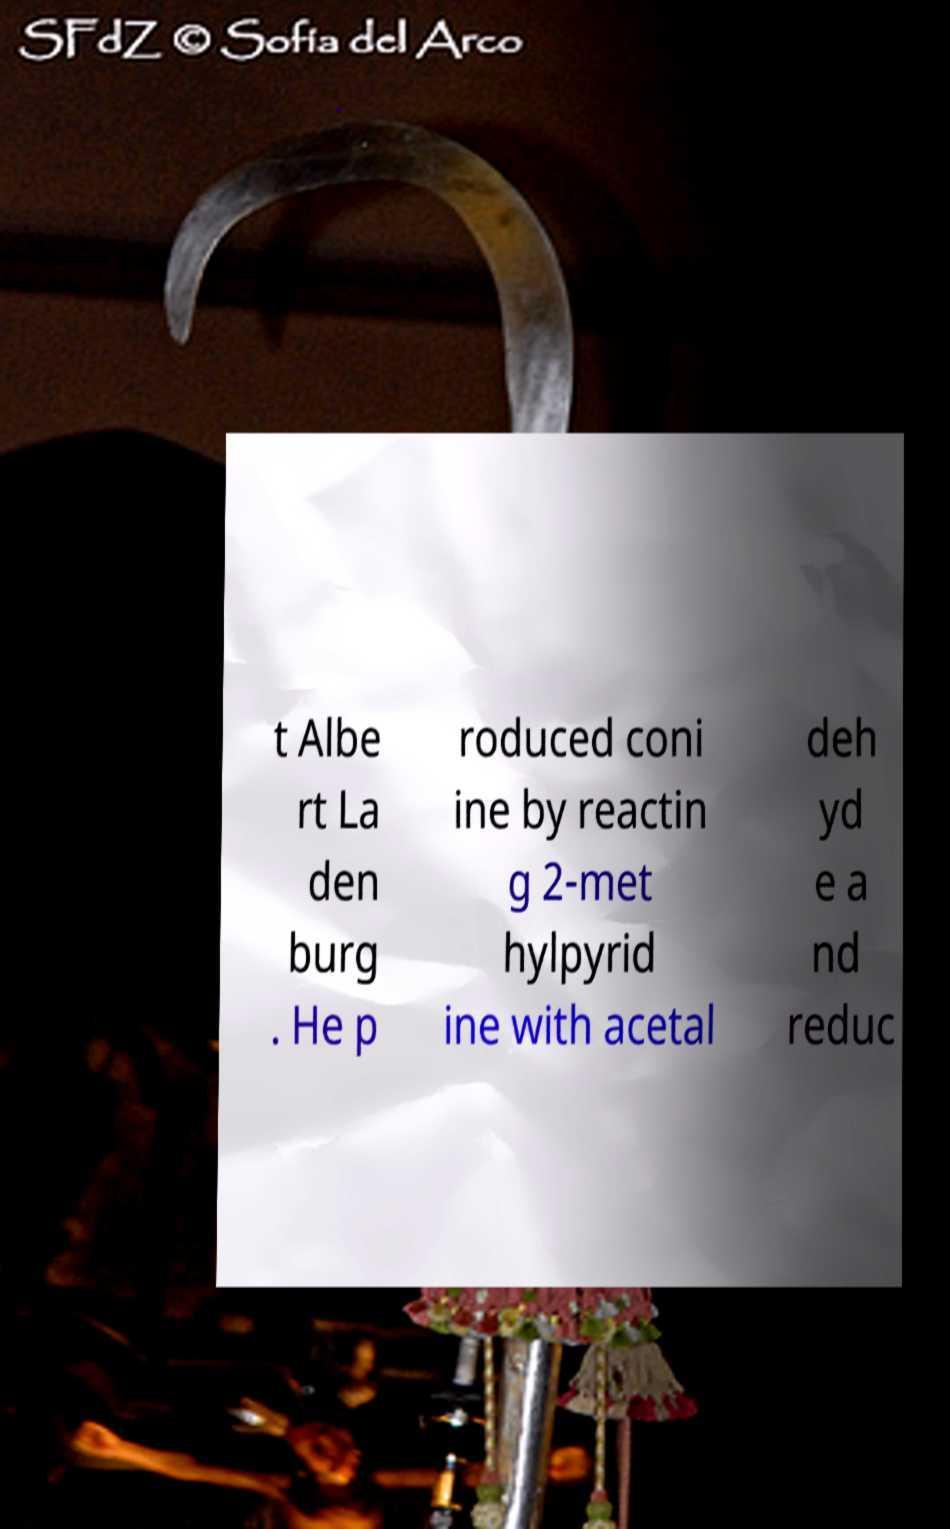Could you extract and type out the text from this image? t Albe rt La den burg . He p roduced coni ine by reactin g 2-met hylpyrid ine with acetal deh yd e a nd reduc 